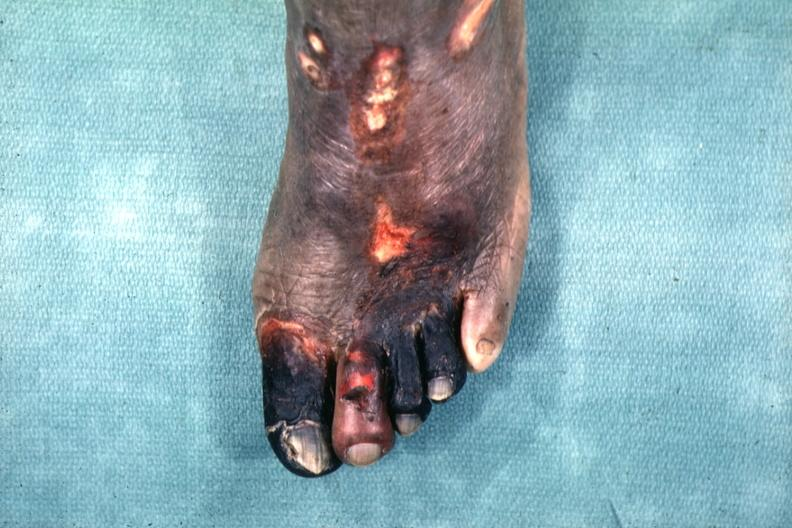what are present?
Answer the question using a single word or phrase. Extremities 